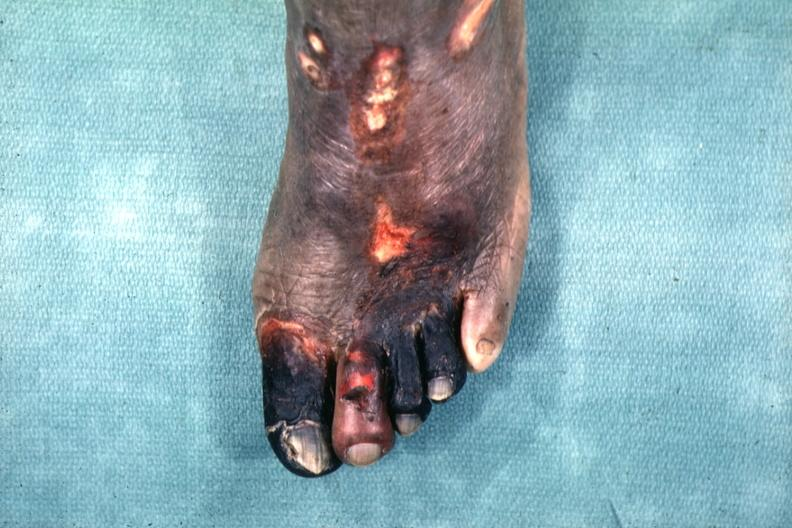what are present?
Answer the question using a single word or phrase. Extremities 